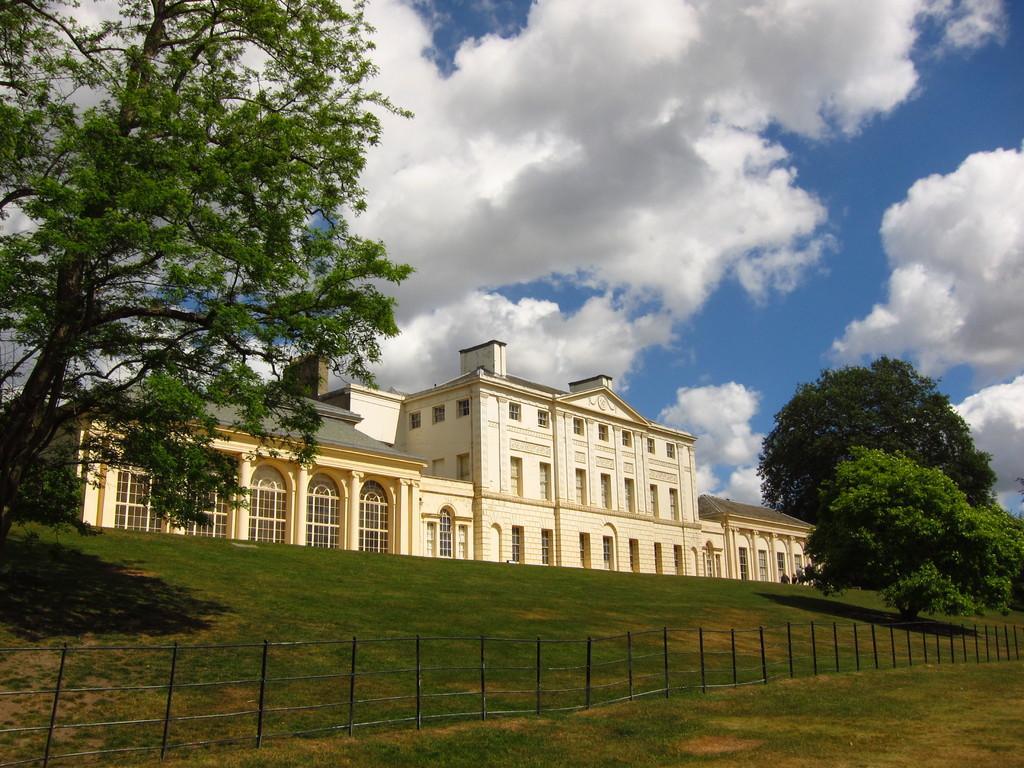Please provide a concise description of this image. This is an outside view. At the bottom of the image I can see the grass and fencing. In the background there is a building. On the both sides of the building I can see the trees. On the top of the image I can see the sky and the clouds. 